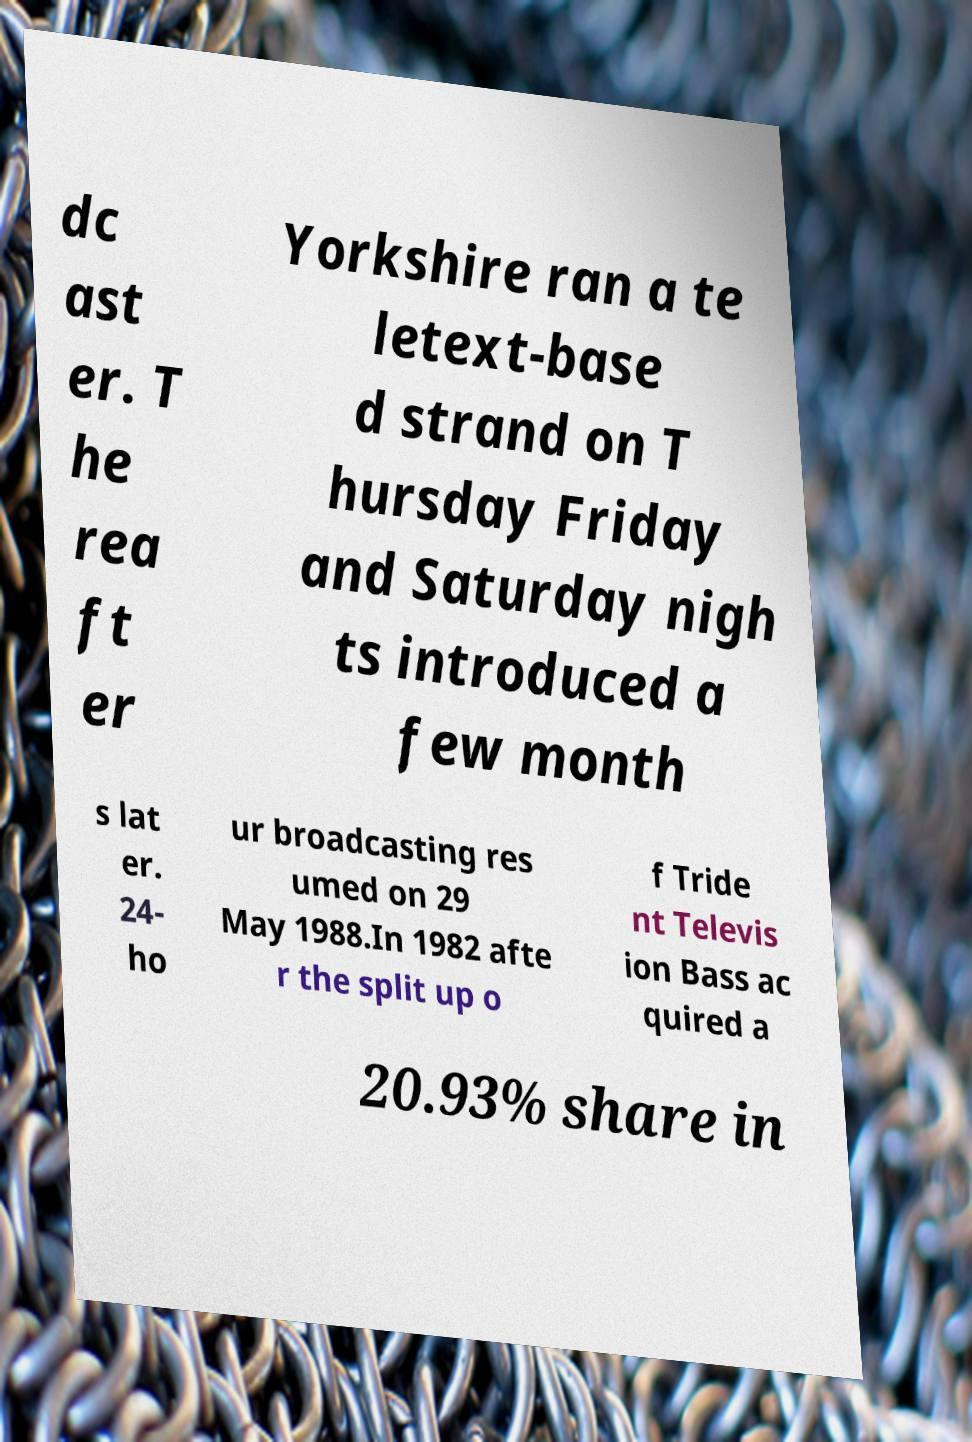What messages or text are displayed in this image? I need them in a readable, typed format. dc ast er. T he rea ft er Yorkshire ran a te letext-base d strand on T hursday Friday and Saturday nigh ts introduced a few month s lat er. 24- ho ur broadcasting res umed on 29 May 1988.In 1982 afte r the split up o f Tride nt Televis ion Bass ac quired a 20.93% share in 